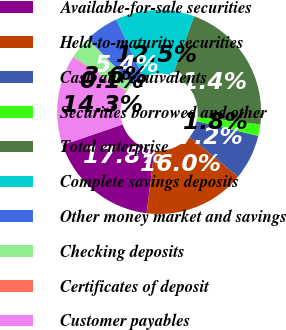Convert chart. <chart><loc_0><loc_0><loc_500><loc_500><pie_chart><fcel>Available-for-sale securities<fcel>Held-to-maturity securities<fcel>Cash and equivalents<fcel>Securities borrowed and other<fcel>Total enterprise<fcel>Complete savings deposits<fcel>Other money market and savings<fcel>Checking deposits<fcel>Certificates of deposit<fcel>Customer payables<nl><fcel>17.8%<fcel>16.03%<fcel>7.16%<fcel>1.84%<fcel>21.35%<fcel>12.48%<fcel>5.39%<fcel>3.61%<fcel>0.07%<fcel>14.26%<nl></chart> 